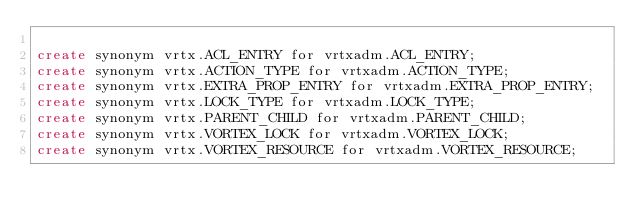Convert code to text. <code><loc_0><loc_0><loc_500><loc_500><_SQL_>
create synonym vrtx.ACL_ENTRY for vrtxadm.ACL_ENTRY;                      
create synonym vrtx.ACTION_TYPE for vrtxadm.ACTION_TYPE;                    
create synonym vrtx.EXTRA_PROP_ENTRY for vrtxadm.EXTRA_PROP_ENTRY;              
create synonym vrtx.LOCK_TYPE for vrtxadm.LOCK_TYPE;                      
create synonym vrtx.PARENT_CHILD for vrtxadm.PARENT_CHILD;                   
create synonym vrtx.VORTEX_LOCK for vrtxadm.VORTEX_LOCK;                    
create synonym vrtx.VORTEX_RESOURCE for vrtxadm.VORTEX_RESOURCE;                

</code> 